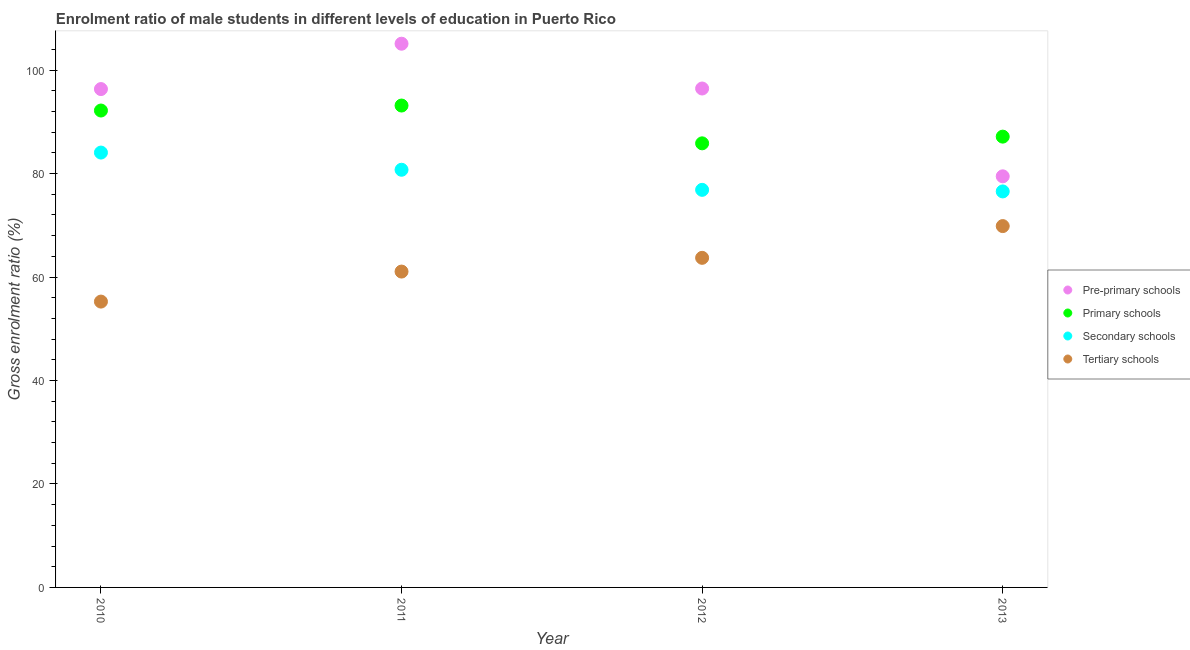Is the number of dotlines equal to the number of legend labels?
Your answer should be compact. Yes. What is the gross enrolment ratio(female) in tertiary schools in 2012?
Ensure brevity in your answer.  63.71. Across all years, what is the maximum gross enrolment ratio(female) in secondary schools?
Give a very brief answer. 84.06. Across all years, what is the minimum gross enrolment ratio(female) in primary schools?
Provide a succinct answer. 85.85. What is the total gross enrolment ratio(female) in pre-primary schools in the graph?
Your answer should be compact. 377.36. What is the difference between the gross enrolment ratio(female) in tertiary schools in 2011 and that in 2013?
Your answer should be very brief. -8.79. What is the difference between the gross enrolment ratio(female) in tertiary schools in 2013 and the gross enrolment ratio(female) in primary schools in 2012?
Offer a terse response. -16. What is the average gross enrolment ratio(female) in secondary schools per year?
Keep it short and to the point. 79.55. In the year 2012, what is the difference between the gross enrolment ratio(female) in secondary schools and gross enrolment ratio(female) in tertiary schools?
Give a very brief answer. 13.14. In how many years, is the gross enrolment ratio(female) in primary schools greater than 96 %?
Provide a short and direct response. 0. What is the ratio of the gross enrolment ratio(female) in primary schools in 2010 to that in 2013?
Your answer should be very brief. 1.06. What is the difference between the highest and the second highest gross enrolment ratio(female) in pre-primary schools?
Your answer should be compact. 8.66. What is the difference between the highest and the lowest gross enrolment ratio(female) in tertiary schools?
Provide a short and direct response. 14.6. Is the sum of the gross enrolment ratio(female) in secondary schools in 2010 and 2011 greater than the maximum gross enrolment ratio(female) in tertiary schools across all years?
Provide a short and direct response. Yes. Is it the case that in every year, the sum of the gross enrolment ratio(female) in pre-primary schools and gross enrolment ratio(female) in primary schools is greater than the gross enrolment ratio(female) in secondary schools?
Provide a succinct answer. Yes. Does the gross enrolment ratio(female) in pre-primary schools monotonically increase over the years?
Ensure brevity in your answer.  No. How many dotlines are there?
Offer a very short reply. 4. How many years are there in the graph?
Offer a very short reply. 4. Are the values on the major ticks of Y-axis written in scientific E-notation?
Provide a succinct answer. No. What is the title of the graph?
Provide a short and direct response. Enrolment ratio of male students in different levels of education in Puerto Rico. Does "Insurance services" appear as one of the legend labels in the graph?
Provide a succinct answer. No. What is the label or title of the X-axis?
Your answer should be very brief. Year. What is the Gross enrolment ratio (%) in Pre-primary schools in 2010?
Ensure brevity in your answer.  96.34. What is the Gross enrolment ratio (%) in Primary schools in 2010?
Give a very brief answer. 92.19. What is the Gross enrolment ratio (%) of Secondary schools in 2010?
Your answer should be very brief. 84.06. What is the Gross enrolment ratio (%) in Tertiary schools in 2010?
Your answer should be very brief. 55.26. What is the Gross enrolment ratio (%) of Pre-primary schools in 2011?
Offer a terse response. 105.11. What is the Gross enrolment ratio (%) of Primary schools in 2011?
Offer a terse response. 93.15. What is the Gross enrolment ratio (%) of Secondary schools in 2011?
Provide a succinct answer. 80.74. What is the Gross enrolment ratio (%) of Tertiary schools in 2011?
Offer a very short reply. 61.06. What is the Gross enrolment ratio (%) in Pre-primary schools in 2012?
Offer a terse response. 96.45. What is the Gross enrolment ratio (%) of Primary schools in 2012?
Provide a short and direct response. 85.85. What is the Gross enrolment ratio (%) in Secondary schools in 2012?
Your answer should be very brief. 76.86. What is the Gross enrolment ratio (%) in Tertiary schools in 2012?
Your answer should be compact. 63.71. What is the Gross enrolment ratio (%) of Pre-primary schools in 2013?
Provide a succinct answer. 79.47. What is the Gross enrolment ratio (%) of Primary schools in 2013?
Ensure brevity in your answer.  87.14. What is the Gross enrolment ratio (%) of Secondary schools in 2013?
Offer a very short reply. 76.55. What is the Gross enrolment ratio (%) in Tertiary schools in 2013?
Provide a succinct answer. 69.85. Across all years, what is the maximum Gross enrolment ratio (%) of Pre-primary schools?
Ensure brevity in your answer.  105.11. Across all years, what is the maximum Gross enrolment ratio (%) of Primary schools?
Offer a terse response. 93.15. Across all years, what is the maximum Gross enrolment ratio (%) of Secondary schools?
Make the answer very short. 84.06. Across all years, what is the maximum Gross enrolment ratio (%) in Tertiary schools?
Ensure brevity in your answer.  69.85. Across all years, what is the minimum Gross enrolment ratio (%) in Pre-primary schools?
Offer a terse response. 79.47. Across all years, what is the minimum Gross enrolment ratio (%) in Primary schools?
Provide a succinct answer. 85.85. Across all years, what is the minimum Gross enrolment ratio (%) in Secondary schools?
Your answer should be compact. 76.55. Across all years, what is the minimum Gross enrolment ratio (%) in Tertiary schools?
Make the answer very short. 55.26. What is the total Gross enrolment ratio (%) in Pre-primary schools in the graph?
Your answer should be very brief. 377.36. What is the total Gross enrolment ratio (%) of Primary schools in the graph?
Give a very brief answer. 358.34. What is the total Gross enrolment ratio (%) of Secondary schools in the graph?
Your answer should be very brief. 318.21. What is the total Gross enrolment ratio (%) in Tertiary schools in the graph?
Your response must be concise. 249.88. What is the difference between the Gross enrolment ratio (%) of Pre-primary schools in 2010 and that in 2011?
Offer a terse response. -8.77. What is the difference between the Gross enrolment ratio (%) of Primary schools in 2010 and that in 2011?
Offer a terse response. -0.96. What is the difference between the Gross enrolment ratio (%) in Secondary schools in 2010 and that in 2011?
Give a very brief answer. 3.32. What is the difference between the Gross enrolment ratio (%) in Tertiary schools in 2010 and that in 2011?
Keep it short and to the point. -5.8. What is the difference between the Gross enrolment ratio (%) of Pre-primary schools in 2010 and that in 2012?
Your answer should be compact. -0.11. What is the difference between the Gross enrolment ratio (%) in Primary schools in 2010 and that in 2012?
Your answer should be compact. 6.34. What is the difference between the Gross enrolment ratio (%) of Secondary schools in 2010 and that in 2012?
Provide a succinct answer. 7.21. What is the difference between the Gross enrolment ratio (%) in Tertiary schools in 2010 and that in 2012?
Keep it short and to the point. -8.46. What is the difference between the Gross enrolment ratio (%) in Pre-primary schools in 2010 and that in 2013?
Provide a short and direct response. 16.87. What is the difference between the Gross enrolment ratio (%) of Primary schools in 2010 and that in 2013?
Offer a very short reply. 5.05. What is the difference between the Gross enrolment ratio (%) of Secondary schools in 2010 and that in 2013?
Keep it short and to the point. 7.51. What is the difference between the Gross enrolment ratio (%) in Tertiary schools in 2010 and that in 2013?
Offer a very short reply. -14.6. What is the difference between the Gross enrolment ratio (%) of Pre-primary schools in 2011 and that in 2012?
Ensure brevity in your answer.  8.66. What is the difference between the Gross enrolment ratio (%) in Primary schools in 2011 and that in 2012?
Provide a short and direct response. 7.31. What is the difference between the Gross enrolment ratio (%) of Secondary schools in 2011 and that in 2012?
Provide a short and direct response. 3.88. What is the difference between the Gross enrolment ratio (%) of Tertiary schools in 2011 and that in 2012?
Provide a succinct answer. -2.65. What is the difference between the Gross enrolment ratio (%) of Pre-primary schools in 2011 and that in 2013?
Provide a succinct answer. 25.63. What is the difference between the Gross enrolment ratio (%) of Primary schools in 2011 and that in 2013?
Your answer should be compact. 6.01. What is the difference between the Gross enrolment ratio (%) in Secondary schools in 2011 and that in 2013?
Your response must be concise. 4.19. What is the difference between the Gross enrolment ratio (%) in Tertiary schools in 2011 and that in 2013?
Your answer should be very brief. -8.79. What is the difference between the Gross enrolment ratio (%) of Pre-primary schools in 2012 and that in 2013?
Provide a succinct answer. 16.98. What is the difference between the Gross enrolment ratio (%) of Primary schools in 2012 and that in 2013?
Make the answer very short. -1.3. What is the difference between the Gross enrolment ratio (%) in Secondary schools in 2012 and that in 2013?
Your answer should be very brief. 0.31. What is the difference between the Gross enrolment ratio (%) of Tertiary schools in 2012 and that in 2013?
Ensure brevity in your answer.  -6.14. What is the difference between the Gross enrolment ratio (%) of Pre-primary schools in 2010 and the Gross enrolment ratio (%) of Primary schools in 2011?
Give a very brief answer. 3.18. What is the difference between the Gross enrolment ratio (%) in Pre-primary schools in 2010 and the Gross enrolment ratio (%) in Secondary schools in 2011?
Provide a succinct answer. 15.6. What is the difference between the Gross enrolment ratio (%) in Pre-primary schools in 2010 and the Gross enrolment ratio (%) in Tertiary schools in 2011?
Provide a succinct answer. 35.28. What is the difference between the Gross enrolment ratio (%) of Primary schools in 2010 and the Gross enrolment ratio (%) of Secondary schools in 2011?
Provide a succinct answer. 11.45. What is the difference between the Gross enrolment ratio (%) of Primary schools in 2010 and the Gross enrolment ratio (%) of Tertiary schools in 2011?
Make the answer very short. 31.13. What is the difference between the Gross enrolment ratio (%) of Secondary schools in 2010 and the Gross enrolment ratio (%) of Tertiary schools in 2011?
Make the answer very short. 23. What is the difference between the Gross enrolment ratio (%) in Pre-primary schools in 2010 and the Gross enrolment ratio (%) in Primary schools in 2012?
Make the answer very short. 10.49. What is the difference between the Gross enrolment ratio (%) of Pre-primary schools in 2010 and the Gross enrolment ratio (%) of Secondary schools in 2012?
Offer a terse response. 19.48. What is the difference between the Gross enrolment ratio (%) in Pre-primary schools in 2010 and the Gross enrolment ratio (%) in Tertiary schools in 2012?
Give a very brief answer. 32.62. What is the difference between the Gross enrolment ratio (%) in Primary schools in 2010 and the Gross enrolment ratio (%) in Secondary schools in 2012?
Give a very brief answer. 15.33. What is the difference between the Gross enrolment ratio (%) of Primary schools in 2010 and the Gross enrolment ratio (%) of Tertiary schools in 2012?
Make the answer very short. 28.48. What is the difference between the Gross enrolment ratio (%) in Secondary schools in 2010 and the Gross enrolment ratio (%) in Tertiary schools in 2012?
Make the answer very short. 20.35. What is the difference between the Gross enrolment ratio (%) of Pre-primary schools in 2010 and the Gross enrolment ratio (%) of Primary schools in 2013?
Offer a terse response. 9.19. What is the difference between the Gross enrolment ratio (%) in Pre-primary schools in 2010 and the Gross enrolment ratio (%) in Secondary schools in 2013?
Provide a short and direct response. 19.79. What is the difference between the Gross enrolment ratio (%) in Pre-primary schools in 2010 and the Gross enrolment ratio (%) in Tertiary schools in 2013?
Ensure brevity in your answer.  26.49. What is the difference between the Gross enrolment ratio (%) of Primary schools in 2010 and the Gross enrolment ratio (%) of Secondary schools in 2013?
Provide a short and direct response. 15.64. What is the difference between the Gross enrolment ratio (%) in Primary schools in 2010 and the Gross enrolment ratio (%) in Tertiary schools in 2013?
Make the answer very short. 22.34. What is the difference between the Gross enrolment ratio (%) in Secondary schools in 2010 and the Gross enrolment ratio (%) in Tertiary schools in 2013?
Make the answer very short. 14.21. What is the difference between the Gross enrolment ratio (%) in Pre-primary schools in 2011 and the Gross enrolment ratio (%) in Primary schools in 2012?
Provide a short and direct response. 19.26. What is the difference between the Gross enrolment ratio (%) in Pre-primary schools in 2011 and the Gross enrolment ratio (%) in Secondary schools in 2012?
Offer a terse response. 28.25. What is the difference between the Gross enrolment ratio (%) of Pre-primary schools in 2011 and the Gross enrolment ratio (%) of Tertiary schools in 2012?
Ensure brevity in your answer.  41.39. What is the difference between the Gross enrolment ratio (%) of Primary schools in 2011 and the Gross enrolment ratio (%) of Secondary schools in 2012?
Ensure brevity in your answer.  16.3. What is the difference between the Gross enrolment ratio (%) in Primary schools in 2011 and the Gross enrolment ratio (%) in Tertiary schools in 2012?
Your answer should be compact. 29.44. What is the difference between the Gross enrolment ratio (%) of Secondary schools in 2011 and the Gross enrolment ratio (%) of Tertiary schools in 2012?
Offer a very short reply. 17.03. What is the difference between the Gross enrolment ratio (%) of Pre-primary schools in 2011 and the Gross enrolment ratio (%) of Primary schools in 2013?
Give a very brief answer. 17.96. What is the difference between the Gross enrolment ratio (%) in Pre-primary schools in 2011 and the Gross enrolment ratio (%) in Secondary schools in 2013?
Your answer should be compact. 28.56. What is the difference between the Gross enrolment ratio (%) in Pre-primary schools in 2011 and the Gross enrolment ratio (%) in Tertiary schools in 2013?
Make the answer very short. 35.26. What is the difference between the Gross enrolment ratio (%) in Primary schools in 2011 and the Gross enrolment ratio (%) in Secondary schools in 2013?
Provide a succinct answer. 16.6. What is the difference between the Gross enrolment ratio (%) of Primary schools in 2011 and the Gross enrolment ratio (%) of Tertiary schools in 2013?
Ensure brevity in your answer.  23.3. What is the difference between the Gross enrolment ratio (%) in Secondary schools in 2011 and the Gross enrolment ratio (%) in Tertiary schools in 2013?
Offer a very short reply. 10.89. What is the difference between the Gross enrolment ratio (%) of Pre-primary schools in 2012 and the Gross enrolment ratio (%) of Primary schools in 2013?
Provide a succinct answer. 9.3. What is the difference between the Gross enrolment ratio (%) of Pre-primary schools in 2012 and the Gross enrolment ratio (%) of Secondary schools in 2013?
Make the answer very short. 19.9. What is the difference between the Gross enrolment ratio (%) of Pre-primary schools in 2012 and the Gross enrolment ratio (%) of Tertiary schools in 2013?
Provide a short and direct response. 26.6. What is the difference between the Gross enrolment ratio (%) of Primary schools in 2012 and the Gross enrolment ratio (%) of Secondary schools in 2013?
Your response must be concise. 9.3. What is the difference between the Gross enrolment ratio (%) in Primary schools in 2012 and the Gross enrolment ratio (%) in Tertiary schools in 2013?
Your response must be concise. 16. What is the difference between the Gross enrolment ratio (%) in Secondary schools in 2012 and the Gross enrolment ratio (%) in Tertiary schools in 2013?
Provide a succinct answer. 7.01. What is the average Gross enrolment ratio (%) of Pre-primary schools per year?
Offer a terse response. 94.34. What is the average Gross enrolment ratio (%) in Primary schools per year?
Provide a succinct answer. 89.58. What is the average Gross enrolment ratio (%) in Secondary schools per year?
Provide a short and direct response. 79.55. What is the average Gross enrolment ratio (%) in Tertiary schools per year?
Your response must be concise. 62.47. In the year 2010, what is the difference between the Gross enrolment ratio (%) of Pre-primary schools and Gross enrolment ratio (%) of Primary schools?
Keep it short and to the point. 4.15. In the year 2010, what is the difference between the Gross enrolment ratio (%) in Pre-primary schools and Gross enrolment ratio (%) in Secondary schools?
Offer a very short reply. 12.27. In the year 2010, what is the difference between the Gross enrolment ratio (%) of Pre-primary schools and Gross enrolment ratio (%) of Tertiary schools?
Make the answer very short. 41.08. In the year 2010, what is the difference between the Gross enrolment ratio (%) of Primary schools and Gross enrolment ratio (%) of Secondary schools?
Provide a succinct answer. 8.13. In the year 2010, what is the difference between the Gross enrolment ratio (%) of Primary schools and Gross enrolment ratio (%) of Tertiary schools?
Offer a terse response. 36.93. In the year 2010, what is the difference between the Gross enrolment ratio (%) of Secondary schools and Gross enrolment ratio (%) of Tertiary schools?
Your answer should be compact. 28.81. In the year 2011, what is the difference between the Gross enrolment ratio (%) in Pre-primary schools and Gross enrolment ratio (%) in Primary schools?
Your answer should be compact. 11.95. In the year 2011, what is the difference between the Gross enrolment ratio (%) in Pre-primary schools and Gross enrolment ratio (%) in Secondary schools?
Offer a terse response. 24.37. In the year 2011, what is the difference between the Gross enrolment ratio (%) of Pre-primary schools and Gross enrolment ratio (%) of Tertiary schools?
Make the answer very short. 44.05. In the year 2011, what is the difference between the Gross enrolment ratio (%) in Primary schools and Gross enrolment ratio (%) in Secondary schools?
Your answer should be compact. 12.41. In the year 2011, what is the difference between the Gross enrolment ratio (%) of Primary schools and Gross enrolment ratio (%) of Tertiary schools?
Give a very brief answer. 32.09. In the year 2011, what is the difference between the Gross enrolment ratio (%) of Secondary schools and Gross enrolment ratio (%) of Tertiary schools?
Your response must be concise. 19.68. In the year 2012, what is the difference between the Gross enrolment ratio (%) of Pre-primary schools and Gross enrolment ratio (%) of Primary schools?
Provide a short and direct response. 10.6. In the year 2012, what is the difference between the Gross enrolment ratio (%) of Pre-primary schools and Gross enrolment ratio (%) of Secondary schools?
Provide a succinct answer. 19.59. In the year 2012, what is the difference between the Gross enrolment ratio (%) in Pre-primary schools and Gross enrolment ratio (%) in Tertiary schools?
Your answer should be compact. 32.73. In the year 2012, what is the difference between the Gross enrolment ratio (%) in Primary schools and Gross enrolment ratio (%) in Secondary schools?
Offer a very short reply. 8.99. In the year 2012, what is the difference between the Gross enrolment ratio (%) in Primary schools and Gross enrolment ratio (%) in Tertiary schools?
Provide a short and direct response. 22.13. In the year 2012, what is the difference between the Gross enrolment ratio (%) in Secondary schools and Gross enrolment ratio (%) in Tertiary schools?
Your answer should be compact. 13.14. In the year 2013, what is the difference between the Gross enrolment ratio (%) in Pre-primary schools and Gross enrolment ratio (%) in Primary schools?
Provide a short and direct response. -7.67. In the year 2013, what is the difference between the Gross enrolment ratio (%) of Pre-primary schools and Gross enrolment ratio (%) of Secondary schools?
Provide a short and direct response. 2.92. In the year 2013, what is the difference between the Gross enrolment ratio (%) of Pre-primary schools and Gross enrolment ratio (%) of Tertiary schools?
Offer a terse response. 9.62. In the year 2013, what is the difference between the Gross enrolment ratio (%) in Primary schools and Gross enrolment ratio (%) in Secondary schools?
Your answer should be very brief. 10.59. In the year 2013, what is the difference between the Gross enrolment ratio (%) of Primary schools and Gross enrolment ratio (%) of Tertiary schools?
Your answer should be very brief. 17.29. In the year 2013, what is the difference between the Gross enrolment ratio (%) of Secondary schools and Gross enrolment ratio (%) of Tertiary schools?
Ensure brevity in your answer.  6.7. What is the ratio of the Gross enrolment ratio (%) of Pre-primary schools in 2010 to that in 2011?
Your answer should be very brief. 0.92. What is the ratio of the Gross enrolment ratio (%) of Secondary schools in 2010 to that in 2011?
Make the answer very short. 1.04. What is the ratio of the Gross enrolment ratio (%) in Tertiary schools in 2010 to that in 2011?
Your answer should be compact. 0.9. What is the ratio of the Gross enrolment ratio (%) in Pre-primary schools in 2010 to that in 2012?
Provide a short and direct response. 1. What is the ratio of the Gross enrolment ratio (%) of Primary schools in 2010 to that in 2012?
Make the answer very short. 1.07. What is the ratio of the Gross enrolment ratio (%) of Secondary schools in 2010 to that in 2012?
Your response must be concise. 1.09. What is the ratio of the Gross enrolment ratio (%) of Tertiary schools in 2010 to that in 2012?
Offer a terse response. 0.87. What is the ratio of the Gross enrolment ratio (%) in Pre-primary schools in 2010 to that in 2013?
Your answer should be very brief. 1.21. What is the ratio of the Gross enrolment ratio (%) of Primary schools in 2010 to that in 2013?
Your answer should be compact. 1.06. What is the ratio of the Gross enrolment ratio (%) of Secondary schools in 2010 to that in 2013?
Your answer should be very brief. 1.1. What is the ratio of the Gross enrolment ratio (%) in Tertiary schools in 2010 to that in 2013?
Your answer should be compact. 0.79. What is the ratio of the Gross enrolment ratio (%) of Pre-primary schools in 2011 to that in 2012?
Give a very brief answer. 1.09. What is the ratio of the Gross enrolment ratio (%) of Primary schools in 2011 to that in 2012?
Keep it short and to the point. 1.09. What is the ratio of the Gross enrolment ratio (%) in Secondary schools in 2011 to that in 2012?
Offer a very short reply. 1.05. What is the ratio of the Gross enrolment ratio (%) in Pre-primary schools in 2011 to that in 2013?
Provide a short and direct response. 1.32. What is the ratio of the Gross enrolment ratio (%) in Primary schools in 2011 to that in 2013?
Provide a succinct answer. 1.07. What is the ratio of the Gross enrolment ratio (%) in Secondary schools in 2011 to that in 2013?
Provide a succinct answer. 1.05. What is the ratio of the Gross enrolment ratio (%) in Tertiary schools in 2011 to that in 2013?
Provide a short and direct response. 0.87. What is the ratio of the Gross enrolment ratio (%) of Pre-primary schools in 2012 to that in 2013?
Your response must be concise. 1.21. What is the ratio of the Gross enrolment ratio (%) in Primary schools in 2012 to that in 2013?
Give a very brief answer. 0.99. What is the ratio of the Gross enrolment ratio (%) in Tertiary schools in 2012 to that in 2013?
Offer a very short reply. 0.91. What is the difference between the highest and the second highest Gross enrolment ratio (%) in Pre-primary schools?
Ensure brevity in your answer.  8.66. What is the difference between the highest and the second highest Gross enrolment ratio (%) of Primary schools?
Keep it short and to the point. 0.96. What is the difference between the highest and the second highest Gross enrolment ratio (%) of Secondary schools?
Ensure brevity in your answer.  3.32. What is the difference between the highest and the second highest Gross enrolment ratio (%) of Tertiary schools?
Offer a very short reply. 6.14. What is the difference between the highest and the lowest Gross enrolment ratio (%) of Pre-primary schools?
Your answer should be compact. 25.63. What is the difference between the highest and the lowest Gross enrolment ratio (%) in Primary schools?
Offer a very short reply. 7.31. What is the difference between the highest and the lowest Gross enrolment ratio (%) of Secondary schools?
Ensure brevity in your answer.  7.51. What is the difference between the highest and the lowest Gross enrolment ratio (%) in Tertiary schools?
Make the answer very short. 14.6. 